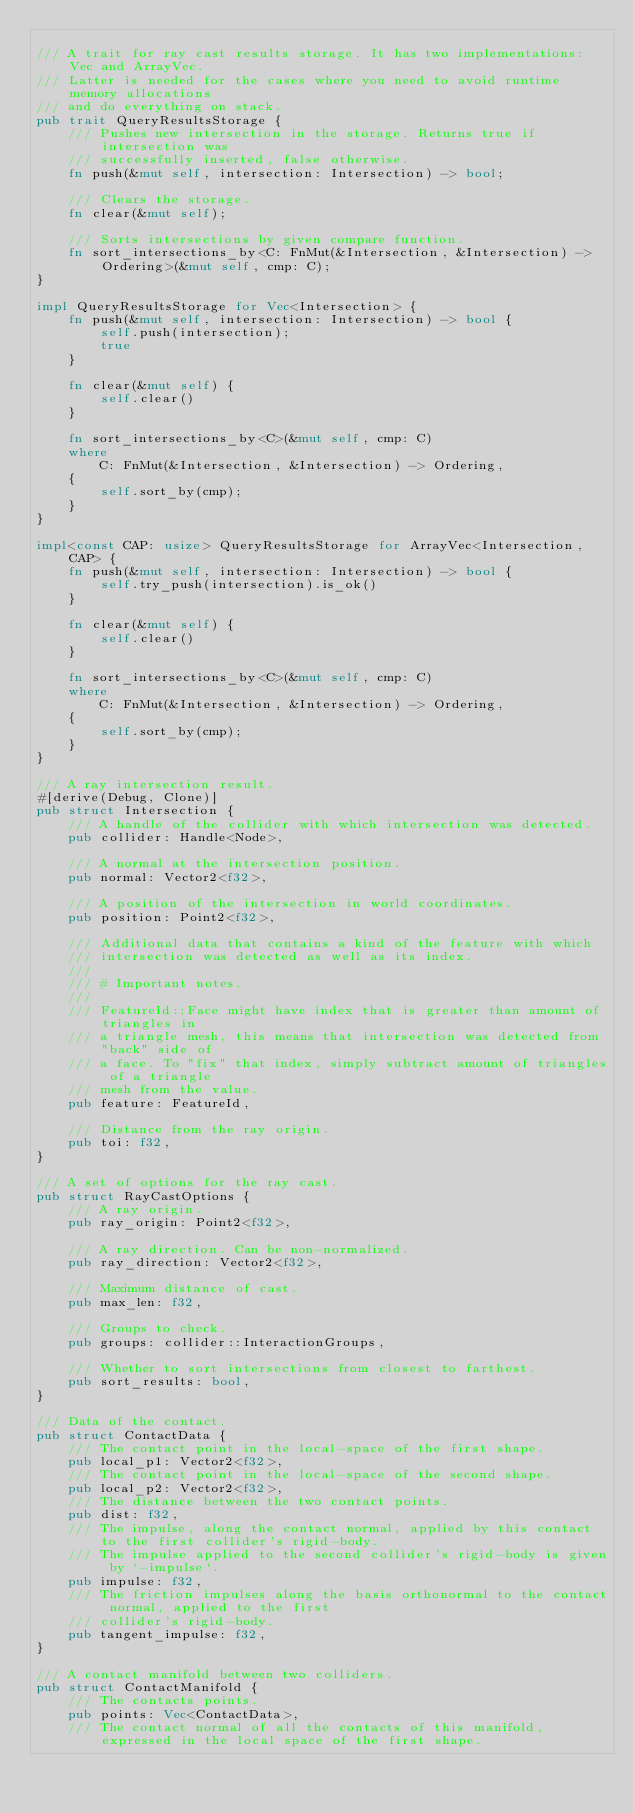<code> <loc_0><loc_0><loc_500><loc_500><_Rust_>
/// A trait for ray cast results storage. It has two implementations: Vec and ArrayVec.
/// Latter is needed for the cases where you need to avoid runtime memory allocations
/// and do everything on stack.
pub trait QueryResultsStorage {
    /// Pushes new intersection in the storage. Returns true if intersection was
    /// successfully inserted, false otherwise.
    fn push(&mut self, intersection: Intersection) -> bool;

    /// Clears the storage.
    fn clear(&mut self);

    /// Sorts intersections by given compare function.
    fn sort_intersections_by<C: FnMut(&Intersection, &Intersection) -> Ordering>(&mut self, cmp: C);
}

impl QueryResultsStorage for Vec<Intersection> {
    fn push(&mut self, intersection: Intersection) -> bool {
        self.push(intersection);
        true
    }

    fn clear(&mut self) {
        self.clear()
    }

    fn sort_intersections_by<C>(&mut self, cmp: C)
    where
        C: FnMut(&Intersection, &Intersection) -> Ordering,
    {
        self.sort_by(cmp);
    }
}

impl<const CAP: usize> QueryResultsStorage for ArrayVec<Intersection, CAP> {
    fn push(&mut self, intersection: Intersection) -> bool {
        self.try_push(intersection).is_ok()
    }

    fn clear(&mut self) {
        self.clear()
    }

    fn sort_intersections_by<C>(&mut self, cmp: C)
    where
        C: FnMut(&Intersection, &Intersection) -> Ordering,
    {
        self.sort_by(cmp);
    }
}

/// A ray intersection result.
#[derive(Debug, Clone)]
pub struct Intersection {
    /// A handle of the collider with which intersection was detected.
    pub collider: Handle<Node>,

    /// A normal at the intersection position.
    pub normal: Vector2<f32>,

    /// A position of the intersection in world coordinates.
    pub position: Point2<f32>,

    /// Additional data that contains a kind of the feature with which
    /// intersection was detected as well as its index.
    ///
    /// # Important notes.
    ///
    /// FeatureId::Face might have index that is greater than amount of triangles in
    /// a triangle mesh, this means that intersection was detected from "back" side of
    /// a face. To "fix" that index, simply subtract amount of triangles of a triangle
    /// mesh from the value.
    pub feature: FeatureId,

    /// Distance from the ray origin.
    pub toi: f32,
}

/// A set of options for the ray cast.
pub struct RayCastOptions {
    /// A ray origin.
    pub ray_origin: Point2<f32>,

    /// A ray direction. Can be non-normalized.
    pub ray_direction: Vector2<f32>,

    /// Maximum distance of cast.
    pub max_len: f32,

    /// Groups to check.
    pub groups: collider::InteractionGroups,

    /// Whether to sort intersections from closest to farthest.
    pub sort_results: bool,
}

/// Data of the contact.
pub struct ContactData {
    /// The contact point in the local-space of the first shape.
    pub local_p1: Vector2<f32>,
    /// The contact point in the local-space of the second shape.
    pub local_p2: Vector2<f32>,
    /// The distance between the two contact points.
    pub dist: f32,
    /// The impulse, along the contact normal, applied by this contact to the first collider's rigid-body.
    /// The impulse applied to the second collider's rigid-body is given by `-impulse`.
    pub impulse: f32,
    /// The friction impulses along the basis orthonormal to the contact normal, applied to the first
    /// collider's rigid-body.
    pub tangent_impulse: f32,
}

/// A contact manifold between two colliders.
pub struct ContactManifold {
    /// The contacts points.
    pub points: Vec<ContactData>,
    /// The contact normal of all the contacts of this manifold, expressed in the local space of the first shape.</code> 